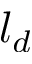<formula> <loc_0><loc_0><loc_500><loc_500>l _ { d }</formula> 